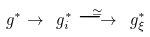Convert formula to latex. <formula><loc_0><loc_0><loc_500><loc_500>\ g ^ { * } \to \ g ^ { * } _ { i } \overset { \simeq } { \longrightarrow } \ g ^ { * } _ { \xi }</formula> 